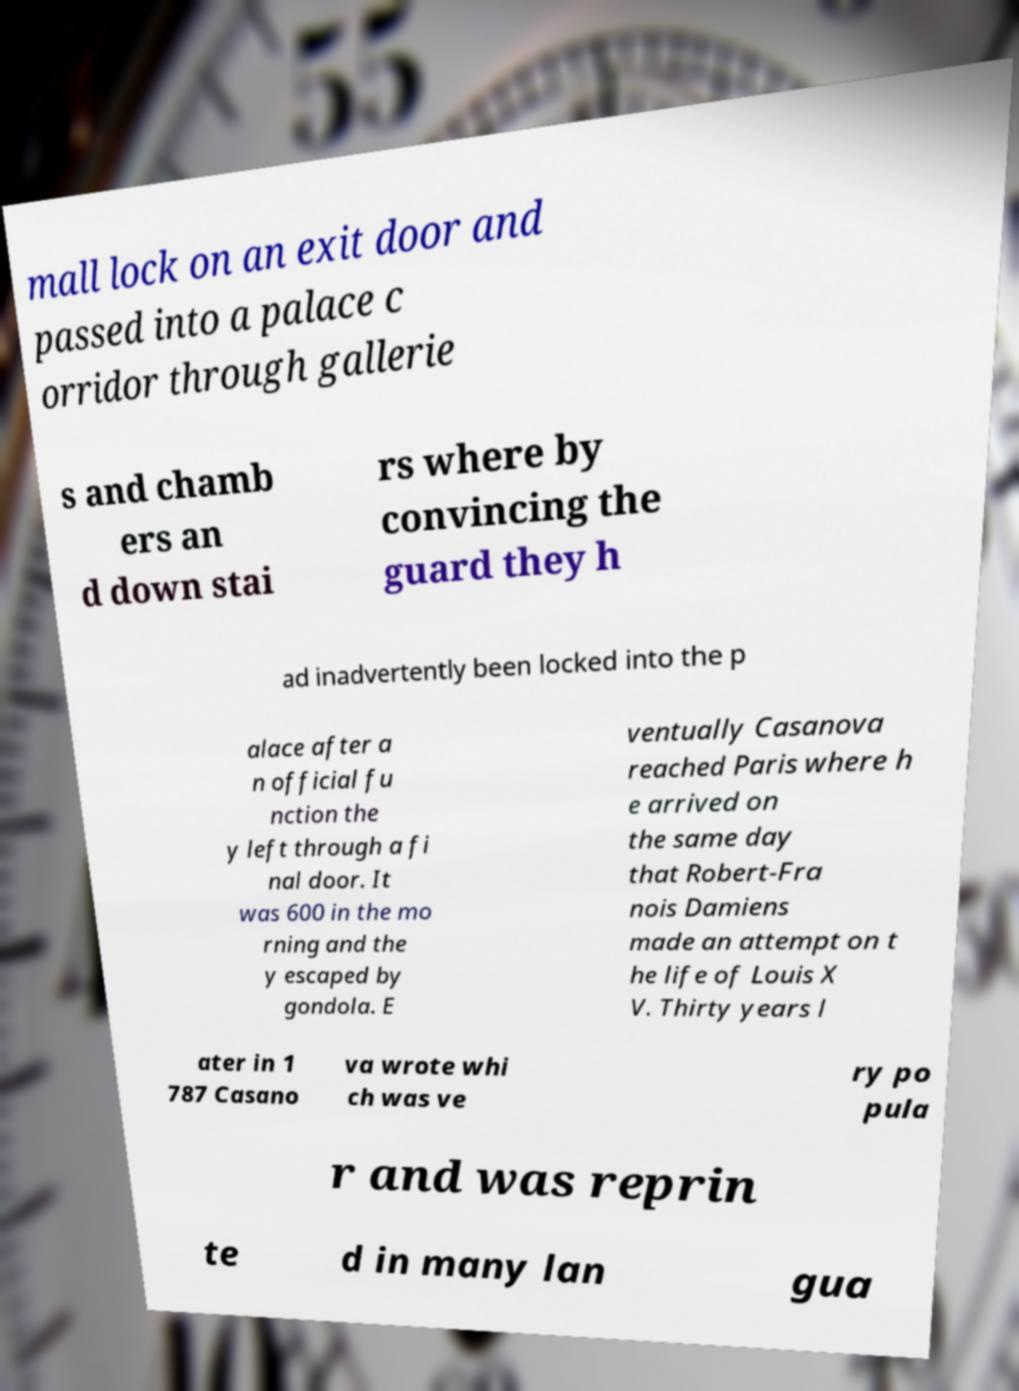Could you assist in decoding the text presented in this image and type it out clearly? mall lock on an exit door and passed into a palace c orridor through gallerie s and chamb ers an d down stai rs where by convincing the guard they h ad inadvertently been locked into the p alace after a n official fu nction the y left through a fi nal door. It was 600 in the mo rning and the y escaped by gondola. E ventually Casanova reached Paris where h e arrived on the same day that Robert-Fra nois Damiens made an attempt on t he life of Louis X V. Thirty years l ater in 1 787 Casano va wrote whi ch was ve ry po pula r and was reprin te d in many lan gua 